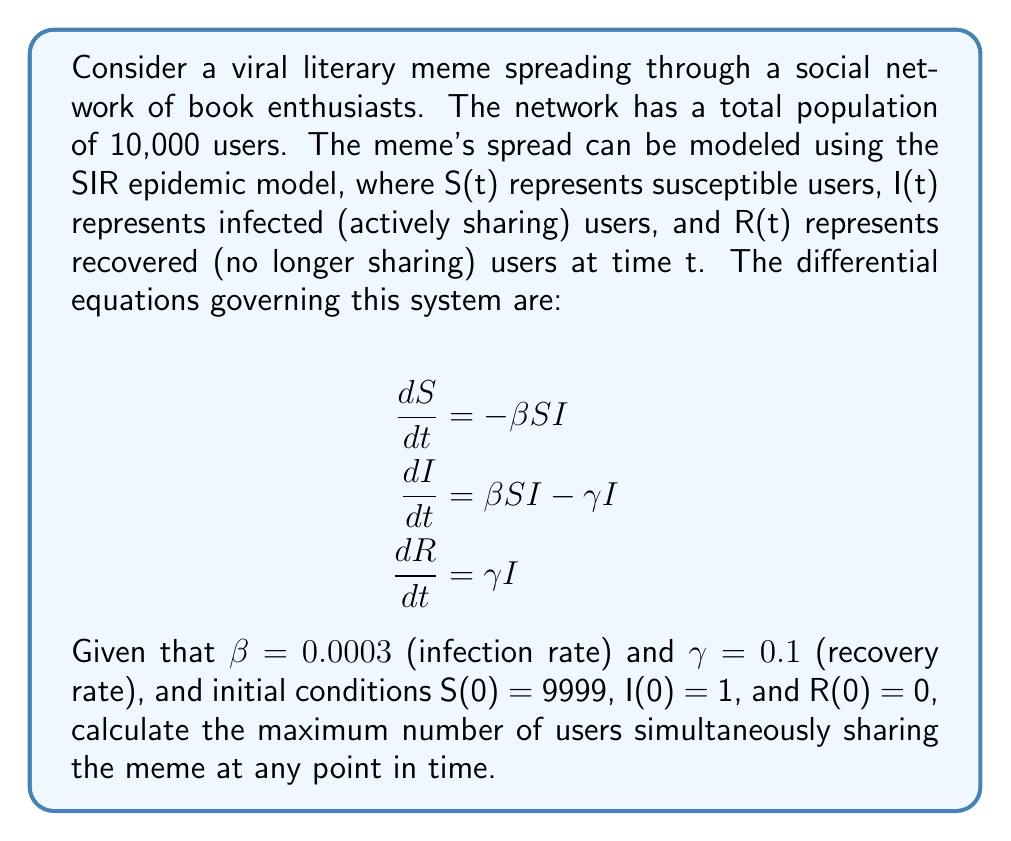Can you answer this question? To solve this problem, we need to follow these steps:

1) First, we need to understand that the maximum number of infected users occurs when $\frac{dI}{dt} = 0$. This is because the number of infected users increases until this point and then starts to decrease.

2) From the second equation in the SIR model:

   $$\frac{dI}{dt} = \beta SI - \gamma I = 0$$

3) This implies:

   $$\beta SI = \gamma I$$

4) Dividing both sides by I (assuming I ≠ 0):

   $$\beta S = \gamma$$

5) Solving for S:

   $$S = \frac{\gamma}{\beta} = \frac{0.1}{0.0003} = 333.33$$

6) This means that when the number of susceptible users reaches approximately 333, the number of infected users will be at its maximum.

7) To find the number of infected users at this point, we can use the fact that in the SIR model, the total population remains constant:

   $$N = S + I + R = 10,000$$

8) We also know that at the start of the epidemic, R(0) = 0, and this number only increases. So at the peak of infection:

   $$10,000 = 333.33 + I_{max} + R$$

9) We don't know R at this point, but we can find it using the relation:

   $$\frac{S}{S_0} = e^{-\frac{\beta}{\gamma}(R-R_0)} = e^{-\frac{0.0003}{0.1}(R-0)}$$

   $$\frac{333.33}{9999} = e^{-0.003R}$$

   $$\ln(0.03333) = -0.003R$$

   $$R = 1151.29$$

10) Substituting this back into the equation from step 8:

    $$10,000 = 333.33 + I_{max} + 1151.29$$

    $$I_{max} = 8515.38$$

Therefore, the maximum number of users simultaneously sharing the meme, rounded to the nearest whole number, is 8515.
Answer: 8515 users 